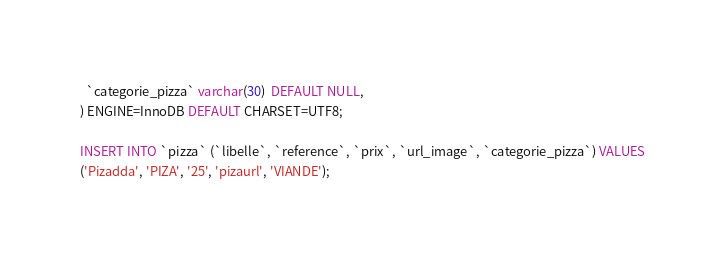Convert code to text. <code><loc_0><loc_0><loc_500><loc_500><_SQL_>  `categorie_pizza` varchar(30)  DEFAULT NULL,
) ENGINE=InnoDB DEFAULT CHARSET=UTF8;

INSERT INTO `pizza` (`libelle`, `reference`, `prix`, `url_image`, `categorie_pizza`) VALUES
('Pizadda', 'PIZA', '25', 'pizaurl', 'VIANDE');</code> 